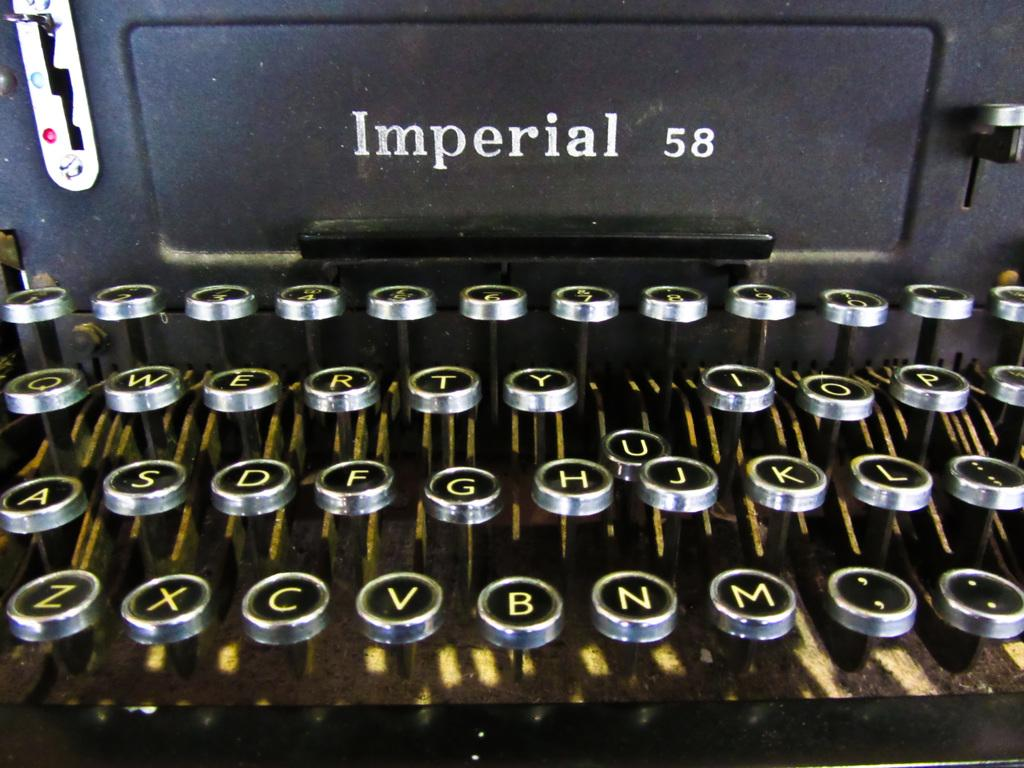<image>
Give a short and clear explanation of the subsequent image. An old fashioned Imperial 58 typewriter with round keys. 